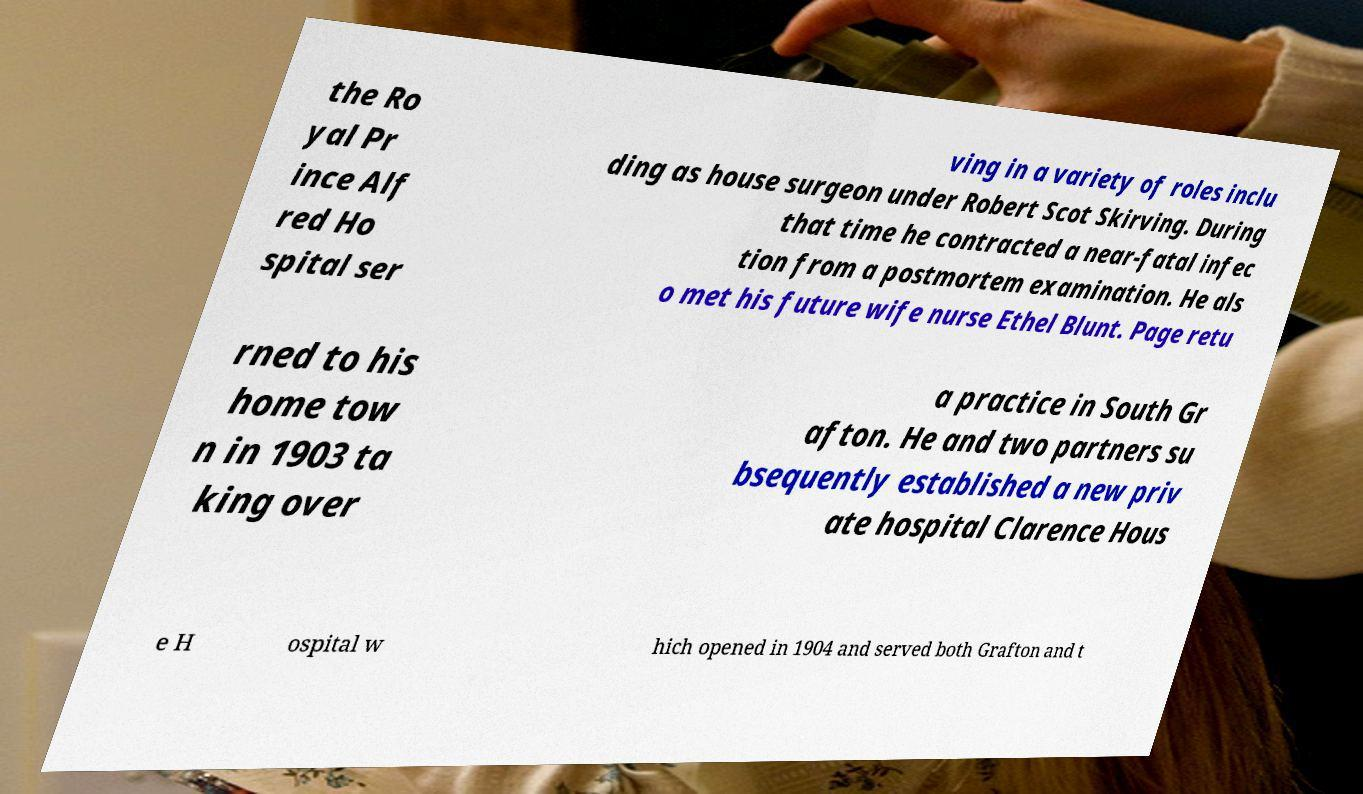For documentation purposes, I need the text within this image transcribed. Could you provide that? the Ro yal Pr ince Alf red Ho spital ser ving in a variety of roles inclu ding as house surgeon under Robert Scot Skirving. During that time he contracted a near-fatal infec tion from a postmortem examination. He als o met his future wife nurse Ethel Blunt. Page retu rned to his home tow n in 1903 ta king over a practice in South Gr afton. He and two partners su bsequently established a new priv ate hospital Clarence Hous e H ospital w hich opened in 1904 and served both Grafton and t 